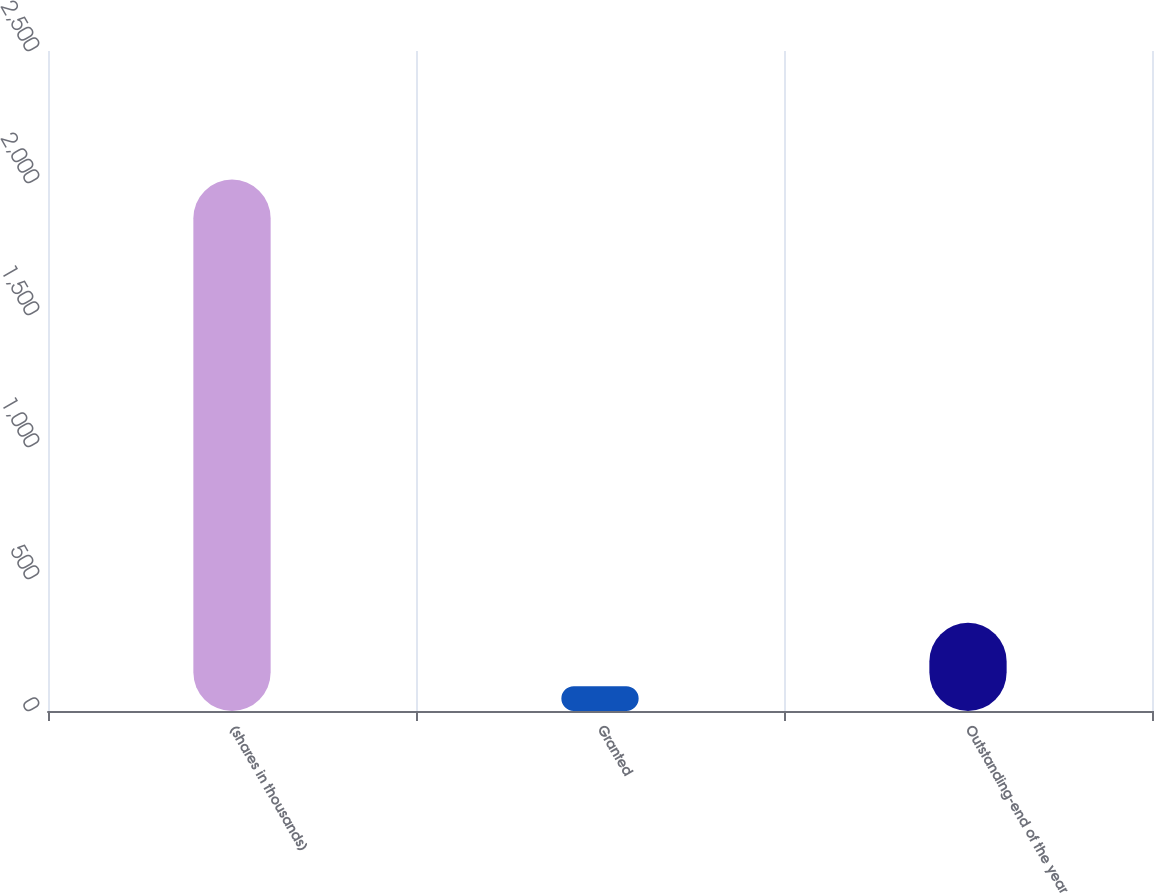Convert chart. <chart><loc_0><loc_0><loc_500><loc_500><bar_chart><fcel>(shares in thousands)<fcel>Granted<fcel>Outstanding-end of the year<nl><fcel>2013<fcel>94<fcel>334<nl></chart> 